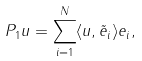<formula> <loc_0><loc_0><loc_500><loc_500>{ P _ { 1 } } u = \sum _ { i = 1 } ^ { N } \langle u , \tilde { e } _ { i } \rangle e _ { i } ,</formula> 